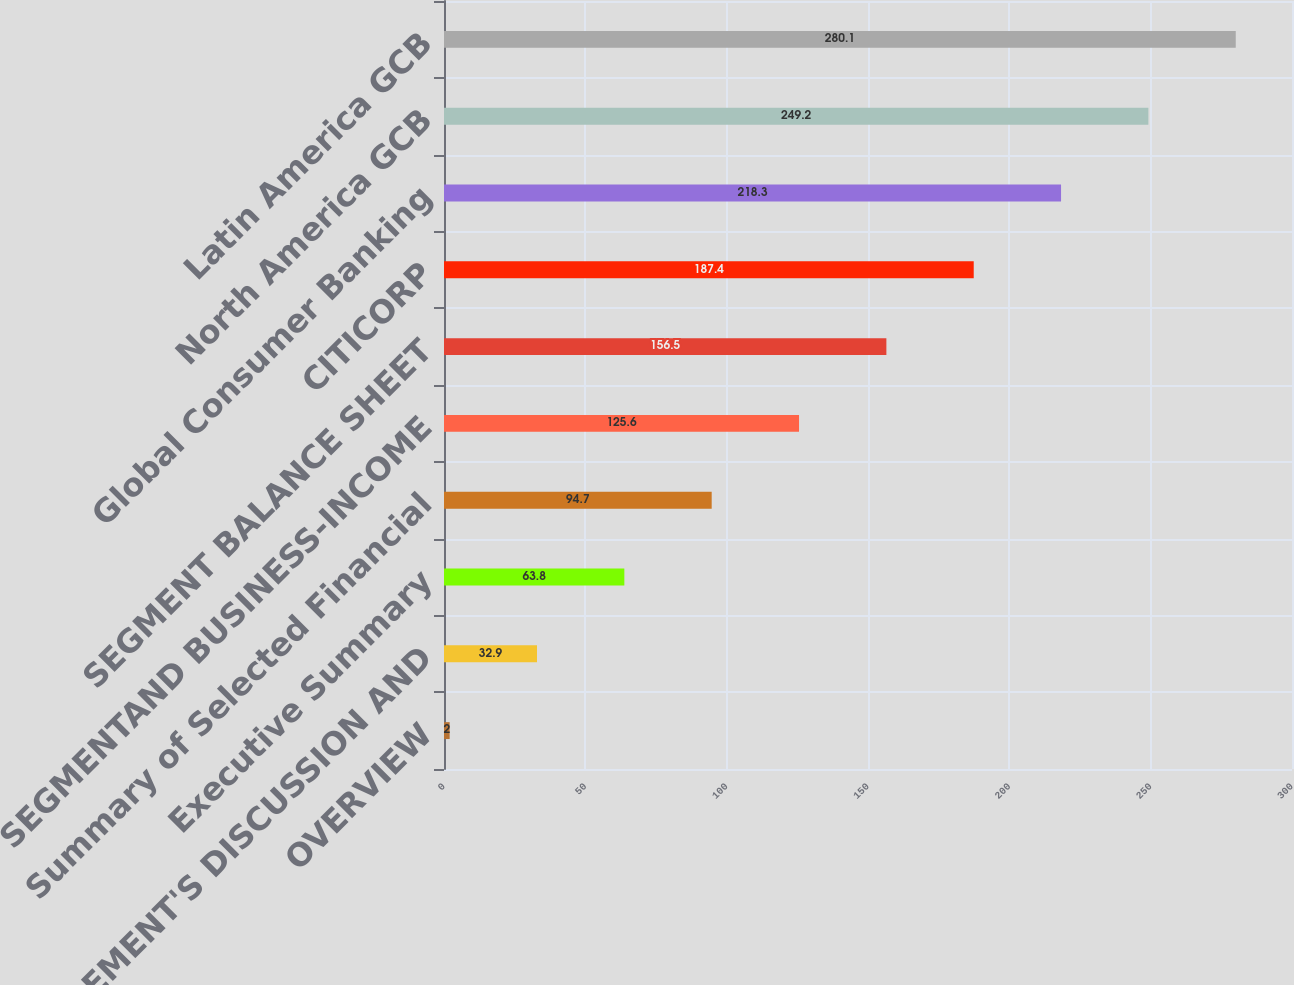Convert chart. <chart><loc_0><loc_0><loc_500><loc_500><bar_chart><fcel>OVERVIEW<fcel>MANAGEMENT'S DISCUSSION AND<fcel>Executive Summary<fcel>Summary of Selected Financial<fcel>SEGMENTAND BUSINESS-INCOME<fcel>SEGMENT BALANCE SHEET<fcel>CITICORP<fcel>Global Consumer Banking<fcel>North America GCB<fcel>Latin America GCB<nl><fcel>2<fcel>32.9<fcel>63.8<fcel>94.7<fcel>125.6<fcel>156.5<fcel>187.4<fcel>218.3<fcel>249.2<fcel>280.1<nl></chart> 